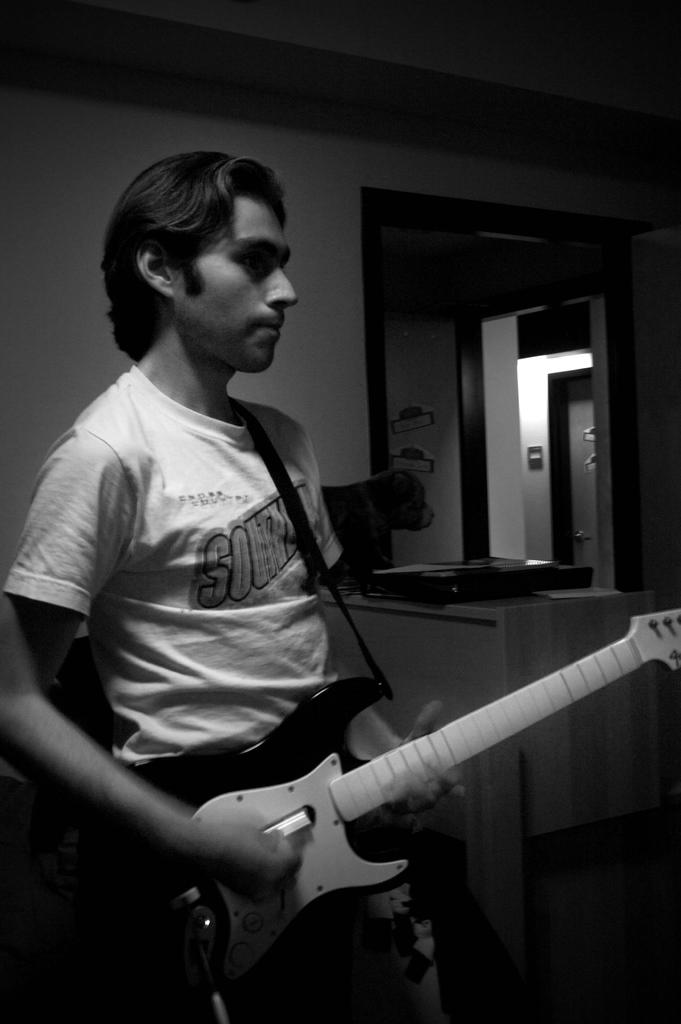What is the main subject of the image? There is a person in the image. What is the person wearing? The person is wearing a white shirt. What activity is the person engaged in? The person is playing a guitar. What type of cub can be seen playing with the person's brain in the image? There is no cub or brain present in the image; it features a person playing a guitar. What type of bun is the person holding in the image? There is no bun present in the image; the person is playing a guitar. 